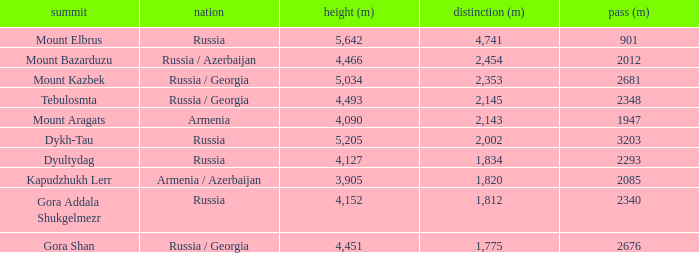What is the Col (m) of Peak Mount Aragats with an Elevation (m) larger than 3,905 and Prominence smaller than 2,143? None. 